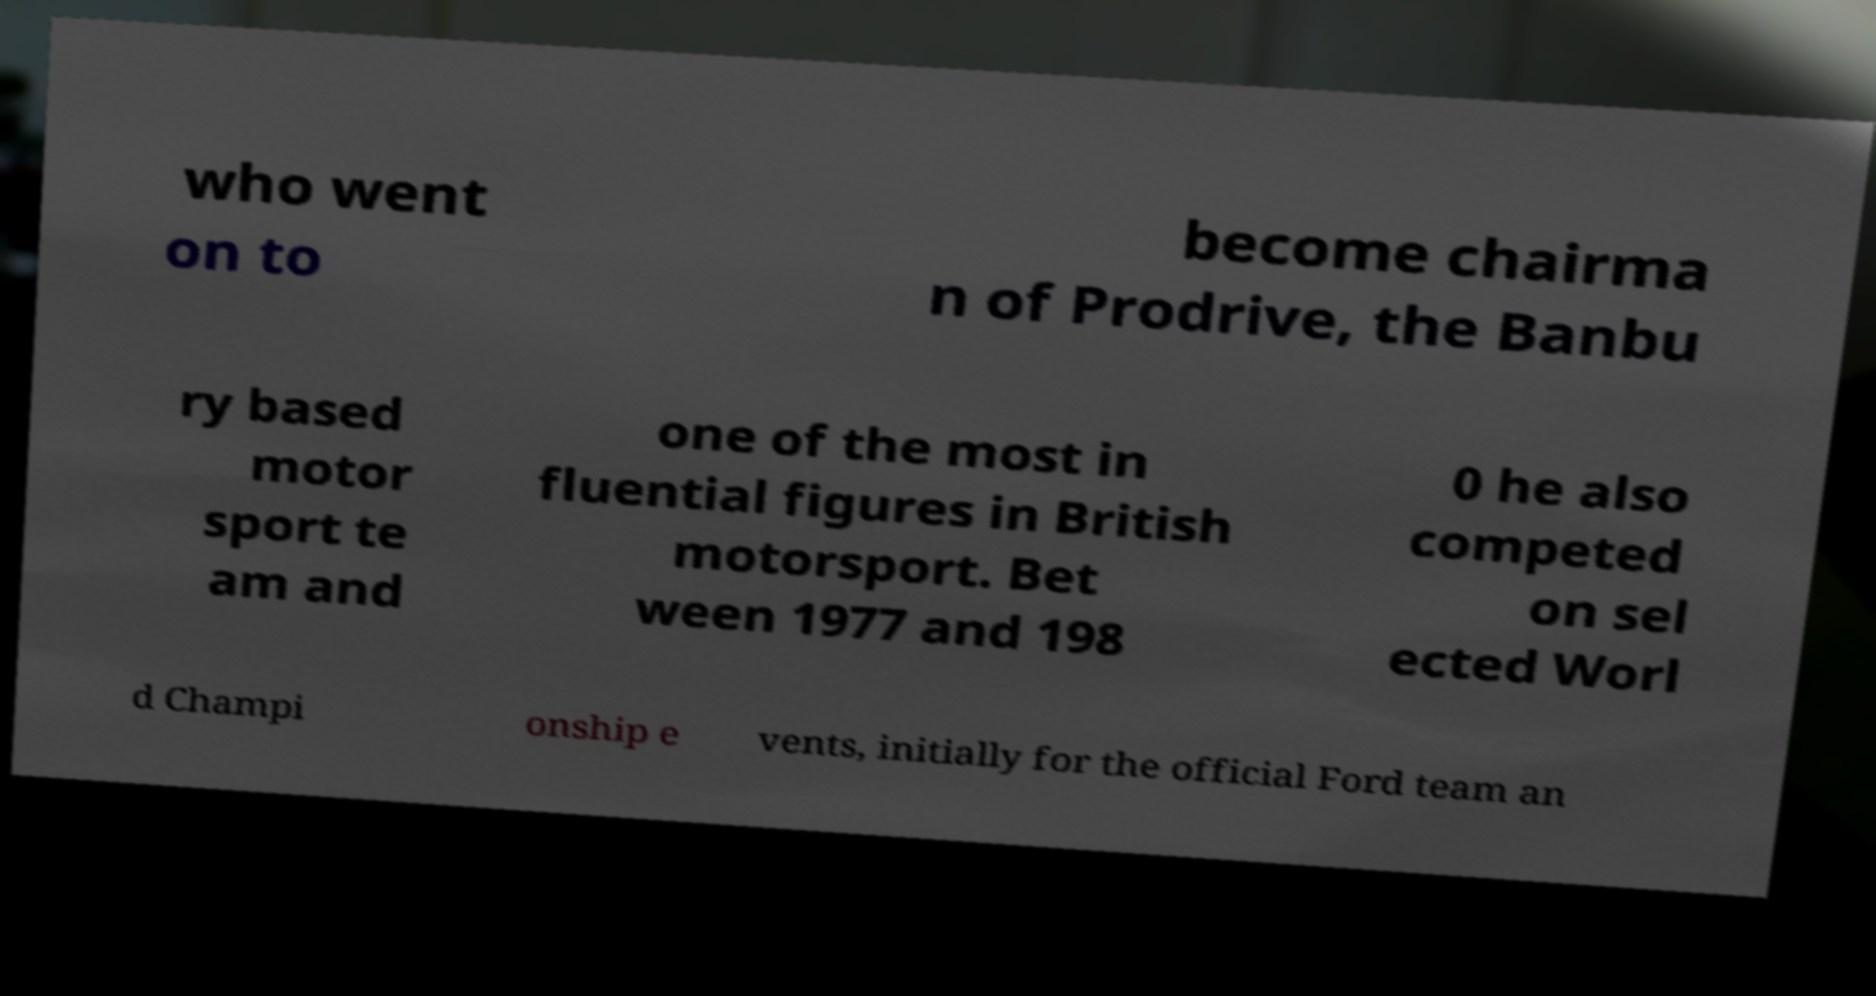What messages or text are displayed in this image? I need them in a readable, typed format. who went on to become chairma n of Prodrive, the Banbu ry based motor sport te am and one of the most in fluential figures in British motorsport. Bet ween 1977 and 198 0 he also competed on sel ected Worl d Champi onship e vents, initially for the official Ford team an 